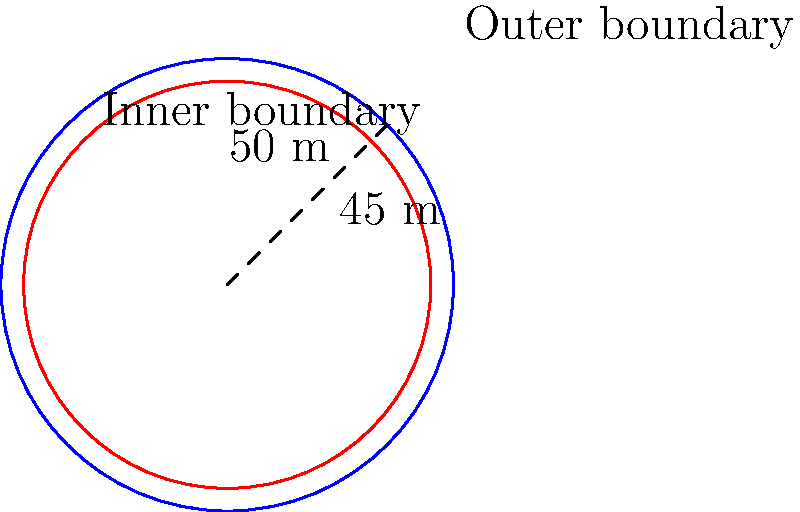The Ceramica Cleopatra FC pitch is represented by two concentric circles, with the outer circle having a radius of 50 meters and the inner circle having a radius of 45 meters. Calculate the area between these two circles, representing the space between the inner and outer boundaries of the pitch. To find the area between two concentric circles, we need to:

1. Calculate the area of the larger circle (outer boundary)
2. Calculate the area of the smaller circle (inner boundary)
3. Subtract the area of the smaller circle from the larger circle

Step 1: Area of the larger circle
$$A_1 = \pi r_1^2 = \pi (50)^2 = 2500\pi \text{ m}^2$$

Step 2: Area of the smaller circle
$$A_2 = \pi r_2^2 = \pi (45)^2 = 2025\pi \text{ m}^2$$

Step 3: Area between the circles
$$A = A_1 - A_2 = 2500\pi - 2025\pi = 475\pi \text{ m}^2$$

Therefore, the area between the two concentric circles representing the inner and outer boundaries of the Ceramica Cleopatra FC pitch is $475\pi \text{ m}^2$.
Answer: $475\pi \text{ m}^2$ 